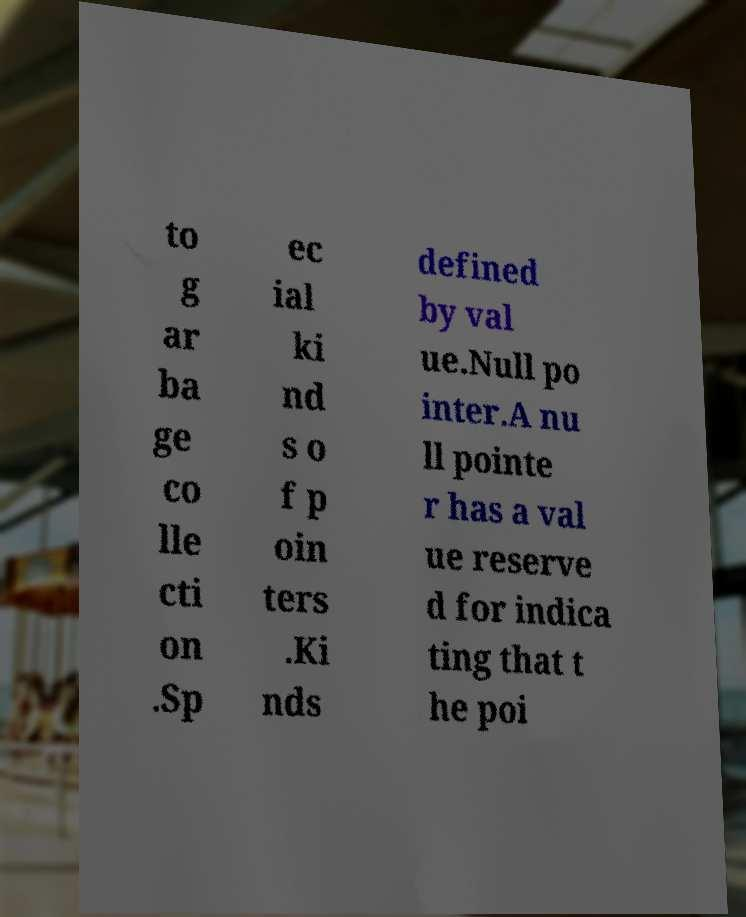Could you assist in decoding the text presented in this image and type it out clearly? to g ar ba ge co lle cti on .Sp ec ial ki nd s o f p oin ters .Ki nds defined by val ue.Null po inter.A nu ll pointe r has a val ue reserve d for indica ting that t he poi 